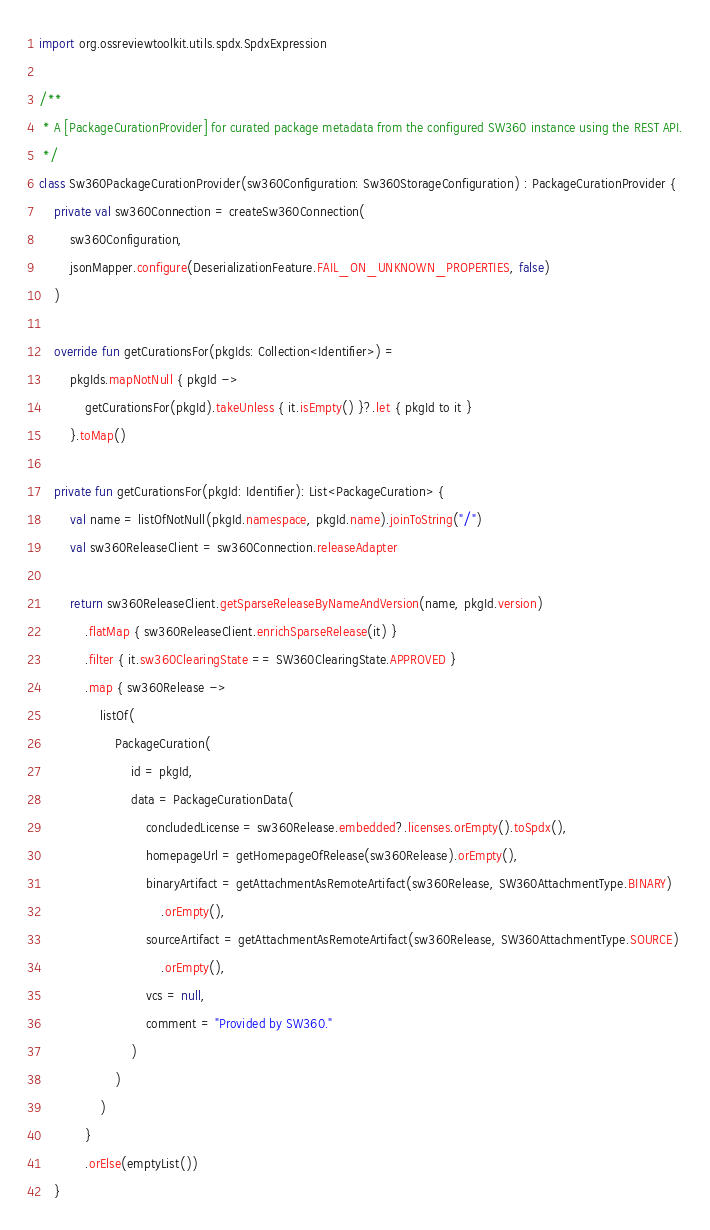Convert code to text. <code><loc_0><loc_0><loc_500><loc_500><_Kotlin_>import org.ossreviewtoolkit.utils.spdx.SpdxExpression

/**
 * A [PackageCurationProvider] for curated package metadata from the configured SW360 instance using the REST API.
 */
class Sw360PackageCurationProvider(sw360Configuration: Sw360StorageConfiguration) : PackageCurationProvider {
    private val sw360Connection = createSw360Connection(
        sw360Configuration,
        jsonMapper.configure(DeserializationFeature.FAIL_ON_UNKNOWN_PROPERTIES, false)
    )

    override fun getCurationsFor(pkgIds: Collection<Identifier>) =
        pkgIds.mapNotNull { pkgId ->
            getCurationsFor(pkgId).takeUnless { it.isEmpty() }?.let { pkgId to it }
        }.toMap()

    private fun getCurationsFor(pkgId: Identifier): List<PackageCuration> {
        val name = listOfNotNull(pkgId.namespace, pkgId.name).joinToString("/")
        val sw360ReleaseClient = sw360Connection.releaseAdapter

        return sw360ReleaseClient.getSparseReleaseByNameAndVersion(name, pkgId.version)
            .flatMap { sw360ReleaseClient.enrichSparseRelease(it) }
            .filter { it.sw360ClearingState == SW360ClearingState.APPROVED }
            .map { sw360Release ->
                listOf(
                    PackageCuration(
                        id = pkgId,
                        data = PackageCurationData(
                            concludedLicense = sw360Release.embedded?.licenses.orEmpty().toSpdx(),
                            homepageUrl = getHomepageOfRelease(sw360Release).orEmpty(),
                            binaryArtifact = getAttachmentAsRemoteArtifact(sw360Release, SW360AttachmentType.BINARY)
                                .orEmpty(),
                            sourceArtifact = getAttachmentAsRemoteArtifact(sw360Release, SW360AttachmentType.SOURCE)
                                .orEmpty(),
                            vcs = null,
                            comment = "Provided by SW360."
                        )
                    )
                )
            }
            .orElse(emptyList())
    }
</code> 